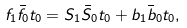<formula> <loc_0><loc_0><loc_500><loc_500>f _ { 1 } \bar { f } _ { 0 } t _ { 0 } = S _ { 1 } \bar { S } _ { 0 } t _ { 0 } + b _ { 1 } \bar { b } _ { 0 } t _ { 0 } ,</formula> 